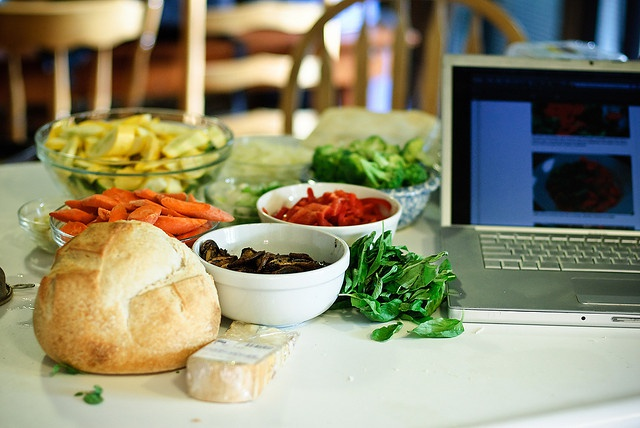Describe the objects in this image and their specific colors. I can see dining table in lightblue, ivory, khaki, darkgray, and olive tones, laptop in lightblue, black, gray, blue, and darkgray tones, chair in lightblue, black, maroon, and olive tones, bowl in lightblue, olive, khaki, and gold tones, and chair in lightblue, tan, beige, black, and brown tones in this image. 